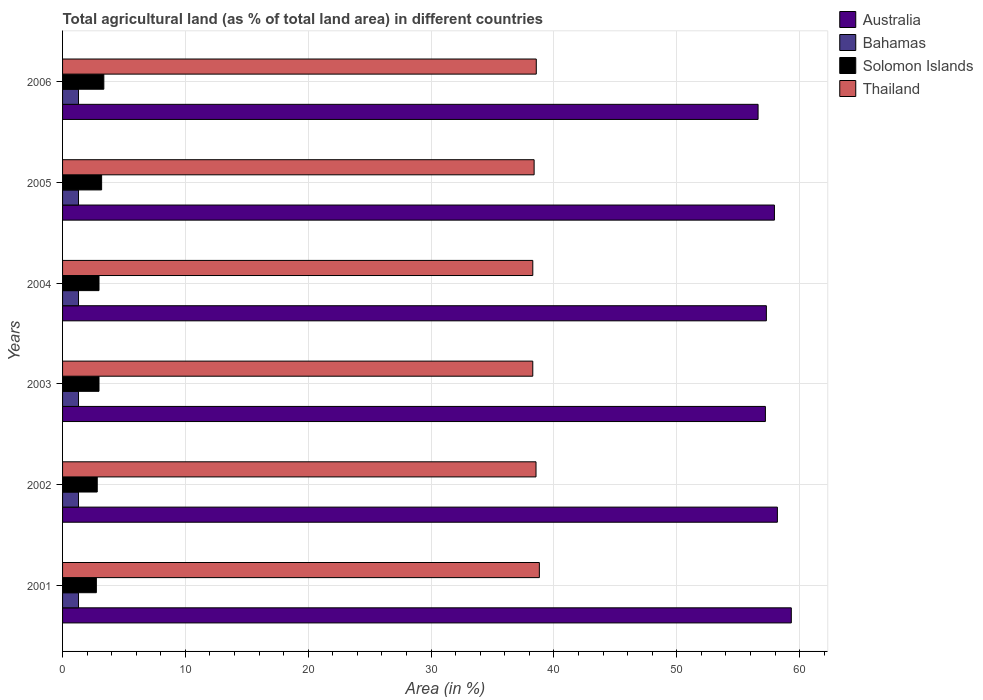How many groups of bars are there?
Provide a short and direct response. 6. Are the number of bars per tick equal to the number of legend labels?
Your response must be concise. Yes. In how many cases, is the number of bars for a given year not equal to the number of legend labels?
Keep it short and to the point. 0. What is the percentage of agricultural land in Australia in 2002?
Ensure brevity in your answer.  58.19. Across all years, what is the maximum percentage of agricultural land in Australia?
Your answer should be very brief. 59.32. Across all years, what is the minimum percentage of agricultural land in Bahamas?
Provide a succinct answer. 1.3. What is the total percentage of agricultural land in Solomon Islands in the graph?
Your answer should be compact. 18.04. What is the difference between the percentage of agricultural land in Bahamas in 2003 and that in 2006?
Give a very brief answer. 0. What is the difference between the percentage of agricultural land in Australia in 2006 and the percentage of agricultural land in Bahamas in 2005?
Give a very brief answer. 55.32. What is the average percentage of agricultural land in Thailand per year?
Your answer should be compact. 38.47. In the year 2003, what is the difference between the percentage of agricultural land in Thailand and percentage of agricultural land in Bahamas?
Provide a succinct answer. 36.98. What is the ratio of the percentage of agricultural land in Solomon Islands in 2002 to that in 2004?
Ensure brevity in your answer.  0.95. What is the difference between the highest and the second highest percentage of agricultural land in Solomon Islands?
Offer a very short reply. 0.18. What is the difference between the highest and the lowest percentage of agricultural land in Solomon Islands?
Make the answer very short. 0.61. Is it the case that in every year, the sum of the percentage of agricultural land in Solomon Islands and percentage of agricultural land in Australia is greater than the sum of percentage of agricultural land in Thailand and percentage of agricultural land in Bahamas?
Give a very brief answer. Yes. What does the 3rd bar from the top in 2001 represents?
Offer a terse response. Bahamas. What does the 4th bar from the bottom in 2006 represents?
Offer a very short reply. Thailand. Is it the case that in every year, the sum of the percentage of agricultural land in Bahamas and percentage of agricultural land in Thailand is greater than the percentage of agricultural land in Solomon Islands?
Your answer should be compact. Yes. How many bars are there?
Offer a terse response. 24. What is the difference between two consecutive major ticks on the X-axis?
Give a very brief answer. 10. Are the values on the major ticks of X-axis written in scientific E-notation?
Give a very brief answer. No. Does the graph contain grids?
Make the answer very short. Yes. How are the legend labels stacked?
Provide a succinct answer. Vertical. What is the title of the graph?
Your answer should be compact. Total agricultural land (as % of total land area) in different countries. What is the label or title of the X-axis?
Your answer should be very brief. Area (in %). What is the Area (in %) in Australia in 2001?
Your answer should be compact. 59.32. What is the Area (in %) of Bahamas in 2001?
Provide a short and direct response. 1.3. What is the Area (in %) in Solomon Islands in 2001?
Provide a short and direct response. 2.75. What is the Area (in %) in Thailand in 2001?
Make the answer very short. 38.81. What is the Area (in %) of Australia in 2002?
Keep it short and to the point. 58.19. What is the Area (in %) in Bahamas in 2002?
Offer a very short reply. 1.3. What is the Area (in %) in Solomon Islands in 2002?
Your answer should be very brief. 2.82. What is the Area (in %) of Thailand in 2002?
Your response must be concise. 38.54. What is the Area (in %) in Australia in 2003?
Your answer should be very brief. 57.21. What is the Area (in %) of Bahamas in 2003?
Keep it short and to the point. 1.3. What is the Area (in %) of Solomon Islands in 2003?
Provide a succinct answer. 2.97. What is the Area (in %) in Thailand in 2003?
Your answer should be compact. 38.27. What is the Area (in %) of Australia in 2004?
Give a very brief answer. 57.29. What is the Area (in %) in Bahamas in 2004?
Provide a short and direct response. 1.3. What is the Area (in %) in Solomon Islands in 2004?
Give a very brief answer. 2.97. What is the Area (in %) in Thailand in 2004?
Give a very brief answer. 38.28. What is the Area (in %) of Australia in 2005?
Ensure brevity in your answer.  57.94. What is the Area (in %) in Bahamas in 2005?
Your response must be concise. 1.3. What is the Area (in %) in Solomon Islands in 2005?
Your answer should be very brief. 3.18. What is the Area (in %) in Thailand in 2005?
Offer a very short reply. 38.38. What is the Area (in %) of Australia in 2006?
Make the answer very short. 56.61. What is the Area (in %) in Bahamas in 2006?
Your response must be concise. 1.3. What is the Area (in %) in Solomon Islands in 2006?
Ensure brevity in your answer.  3.36. What is the Area (in %) of Thailand in 2006?
Provide a short and direct response. 38.56. Across all years, what is the maximum Area (in %) of Australia?
Your answer should be very brief. 59.32. Across all years, what is the maximum Area (in %) in Bahamas?
Make the answer very short. 1.3. Across all years, what is the maximum Area (in %) of Solomon Islands?
Provide a succinct answer. 3.36. Across all years, what is the maximum Area (in %) of Thailand?
Your answer should be compact. 38.81. Across all years, what is the minimum Area (in %) of Australia?
Your answer should be compact. 56.61. Across all years, what is the minimum Area (in %) of Bahamas?
Ensure brevity in your answer.  1.3. Across all years, what is the minimum Area (in %) of Solomon Islands?
Offer a very short reply. 2.75. Across all years, what is the minimum Area (in %) in Thailand?
Your answer should be very brief. 38.27. What is the total Area (in %) of Australia in the graph?
Your answer should be very brief. 346.56. What is the total Area (in %) in Bahamas in the graph?
Keep it short and to the point. 7.79. What is the total Area (in %) of Solomon Islands in the graph?
Your answer should be very brief. 18.04. What is the total Area (in %) in Thailand in the graph?
Your answer should be compact. 230.84. What is the difference between the Area (in %) in Australia in 2001 and that in 2002?
Make the answer very short. 1.13. What is the difference between the Area (in %) in Bahamas in 2001 and that in 2002?
Offer a terse response. 0. What is the difference between the Area (in %) of Solomon Islands in 2001 and that in 2002?
Your answer should be very brief. -0.07. What is the difference between the Area (in %) of Thailand in 2001 and that in 2002?
Your answer should be very brief. 0.27. What is the difference between the Area (in %) of Australia in 2001 and that in 2003?
Your answer should be very brief. 2.11. What is the difference between the Area (in %) in Solomon Islands in 2001 and that in 2003?
Offer a very short reply. -0.21. What is the difference between the Area (in %) of Thailand in 2001 and that in 2003?
Offer a very short reply. 0.54. What is the difference between the Area (in %) in Australia in 2001 and that in 2004?
Give a very brief answer. 2.03. What is the difference between the Area (in %) of Solomon Islands in 2001 and that in 2004?
Offer a very short reply. -0.21. What is the difference between the Area (in %) in Thailand in 2001 and that in 2004?
Your response must be concise. 0.53. What is the difference between the Area (in %) in Australia in 2001 and that in 2005?
Your response must be concise. 1.37. What is the difference between the Area (in %) in Bahamas in 2001 and that in 2005?
Provide a short and direct response. 0. What is the difference between the Area (in %) in Solomon Islands in 2001 and that in 2005?
Provide a short and direct response. -0.43. What is the difference between the Area (in %) in Thailand in 2001 and that in 2005?
Make the answer very short. 0.43. What is the difference between the Area (in %) in Australia in 2001 and that in 2006?
Offer a very short reply. 2.7. What is the difference between the Area (in %) of Solomon Islands in 2001 and that in 2006?
Provide a succinct answer. -0.61. What is the difference between the Area (in %) of Thailand in 2001 and that in 2006?
Your response must be concise. 0.25. What is the difference between the Area (in %) in Australia in 2002 and that in 2003?
Ensure brevity in your answer.  0.98. What is the difference between the Area (in %) of Bahamas in 2002 and that in 2003?
Make the answer very short. 0. What is the difference between the Area (in %) of Solomon Islands in 2002 and that in 2003?
Offer a terse response. -0.14. What is the difference between the Area (in %) of Thailand in 2002 and that in 2003?
Provide a short and direct response. 0.26. What is the difference between the Area (in %) of Australia in 2002 and that in 2004?
Provide a short and direct response. 0.9. What is the difference between the Area (in %) of Bahamas in 2002 and that in 2004?
Give a very brief answer. 0. What is the difference between the Area (in %) of Solomon Islands in 2002 and that in 2004?
Your answer should be compact. -0.14. What is the difference between the Area (in %) of Thailand in 2002 and that in 2004?
Your answer should be very brief. 0.26. What is the difference between the Area (in %) in Australia in 2002 and that in 2005?
Your response must be concise. 0.24. What is the difference between the Area (in %) of Solomon Islands in 2002 and that in 2005?
Keep it short and to the point. -0.36. What is the difference between the Area (in %) of Thailand in 2002 and that in 2005?
Ensure brevity in your answer.  0.15. What is the difference between the Area (in %) in Australia in 2002 and that in 2006?
Ensure brevity in your answer.  1.57. What is the difference between the Area (in %) in Bahamas in 2002 and that in 2006?
Your answer should be very brief. 0. What is the difference between the Area (in %) of Solomon Islands in 2002 and that in 2006?
Provide a succinct answer. -0.54. What is the difference between the Area (in %) in Thailand in 2002 and that in 2006?
Give a very brief answer. -0.02. What is the difference between the Area (in %) of Australia in 2003 and that in 2004?
Keep it short and to the point. -0.08. What is the difference between the Area (in %) of Thailand in 2003 and that in 2004?
Provide a short and direct response. -0. What is the difference between the Area (in %) of Australia in 2003 and that in 2005?
Offer a very short reply. -0.74. What is the difference between the Area (in %) of Bahamas in 2003 and that in 2005?
Offer a very short reply. 0. What is the difference between the Area (in %) of Solomon Islands in 2003 and that in 2005?
Offer a terse response. -0.21. What is the difference between the Area (in %) in Thailand in 2003 and that in 2005?
Ensure brevity in your answer.  -0.11. What is the difference between the Area (in %) in Australia in 2003 and that in 2006?
Provide a succinct answer. 0.6. What is the difference between the Area (in %) in Bahamas in 2003 and that in 2006?
Make the answer very short. 0. What is the difference between the Area (in %) of Solomon Islands in 2003 and that in 2006?
Give a very brief answer. -0.39. What is the difference between the Area (in %) of Thailand in 2003 and that in 2006?
Offer a very short reply. -0.29. What is the difference between the Area (in %) of Australia in 2004 and that in 2005?
Ensure brevity in your answer.  -0.66. What is the difference between the Area (in %) in Bahamas in 2004 and that in 2005?
Offer a very short reply. 0. What is the difference between the Area (in %) in Solomon Islands in 2004 and that in 2005?
Give a very brief answer. -0.21. What is the difference between the Area (in %) in Thailand in 2004 and that in 2005?
Provide a short and direct response. -0.11. What is the difference between the Area (in %) of Australia in 2004 and that in 2006?
Offer a very short reply. 0.67. What is the difference between the Area (in %) in Bahamas in 2004 and that in 2006?
Your answer should be very brief. 0. What is the difference between the Area (in %) in Solomon Islands in 2004 and that in 2006?
Offer a very short reply. -0.39. What is the difference between the Area (in %) in Thailand in 2004 and that in 2006?
Ensure brevity in your answer.  -0.28. What is the difference between the Area (in %) of Australia in 2005 and that in 2006?
Ensure brevity in your answer.  1.33. What is the difference between the Area (in %) in Bahamas in 2005 and that in 2006?
Your answer should be compact. 0. What is the difference between the Area (in %) of Solomon Islands in 2005 and that in 2006?
Offer a terse response. -0.18. What is the difference between the Area (in %) in Thailand in 2005 and that in 2006?
Give a very brief answer. -0.18. What is the difference between the Area (in %) in Australia in 2001 and the Area (in %) in Bahamas in 2002?
Keep it short and to the point. 58.02. What is the difference between the Area (in %) of Australia in 2001 and the Area (in %) of Solomon Islands in 2002?
Give a very brief answer. 56.5. What is the difference between the Area (in %) of Australia in 2001 and the Area (in %) of Thailand in 2002?
Your response must be concise. 20.78. What is the difference between the Area (in %) in Bahamas in 2001 and the Area (in %) in Solomon Islands in 2002?
Your response must be concise. -1.52. What is the difference between the Area (in %) of Bahamas in 2001 and the Area (in %) of Thailand in 2002?
Provide a short and direct response. -37.24. What is the difference between the Area (in %) of Solomon Islands in 2001 and the Area (in %) of Thailand in 2002?
Your answer should be compact. -35.79. What is the difference between the Area (in %) of Australia in 2001 and the Area (in %) of Bahamas in 2003?
Give a very brief answer. 58.02. What is the difference between the Area (in %) of Australia in 2001 and the Area (in %) of Solomon Islands in 2003?
Keep it short and to the point. 56.35. What is the difference between the Area (in %) in Australia in 2001 and the Area (in %) in Thailand in 2003?
Your answer should be very brief. 21.04. What is the difference between the Area (in %) in Bahamas in 2001 and the Area (in %) in Solomon Islands in 2003?
Ensure brevity in your answer.  -1.67. What is the difference between the Area (in %) of Bahamas in 2001 and the Area (in %) of Thailand in 2003?
Your answer should be compact. -36.98. What is the difference between the Area (in %) of Solomon Islands in 2001 and the Area (in %) of Thailand in 2003?
Your answer should be compact. -35.52. What is the difference between the Area (in %) in Australia in 2001 and the Area (in %) in Bahamas in 2004?
Give a very brief answer. 58.02. What is the difference between the Area (in %) of Australia in 2001 and the Area (in %) of Solomon Islands in 2004?
Offer a terse response. 56.35. What is the difference between the Area (in %) in Australia in 2001 and the Area (in %) in Thailand in 2004?
Offer a very short reply. 21.04. What is the difference between the Area (in %) of Bahamas in 2001 and the Area (in %) of Solomon Islands in 2004?
Offer a very short reply. -1.67. What is the difference between the Area (in %) in Bahamas in 2001 and the Area (in %) in Thailand in 2004?
Provide a succinct answer. -36.98. What is the difference between the Area (in %) in Solomon Islands in 2001 and the Area (in %) in Thailand in 2004?
Offer a very short reply. -35.53. What is the difference between the Area (in %) in Australia in 2001 and the Area (in %) in Bahamas in 2005?
Your answer should be very brief. 58.02. What is the difference between the Area (in %) of Australia in 2001 and the Area (in %) of Solomon Islands in 2005?
Provide a short and direct response. 56.14. What is the difference between the Area (in %) in Australia in 2001 and the Area (in %) in Thailand in 2005?
Your response must be concise. 20.93. What is the difference between the Area (in %) of Bahamas in 2001 and the Area (in %) of Solomon Islands in 2005?
Ensure brevity in your answer.  -1.88. What is the difference between the Area (in %) in Bahamas in 2001 and the Area (in %) in Thailand in 2005?
Your answer should be very brief. -37.09. What is the difference between the Area (in %) of Solomon Islands in 2001 and the Area (in %) of Thailand in 2005?
Your answer should be very brief. -35.63. What is the difference between the Area (in %) in Australia in 2001 and the Area (in %) in Bahamas in 2006?
Give a very brief answer. 58.02. What is the difference between the Area (in %) in Australia in 2001 and the Area (in %) in Solomon Islands in 2006?
Provide a succinct answer. 55.96. What is the difference between the Area (in %) in Australia in 2001 and the Area (in %) in Thailand in 2006?
Offer a very short reply. 20.76. What is the difference between the Area (in %) in Bahamas in 2001 and the Area (in %) in Solomon Islands in 2006?
Provide a short and direct response. -2.06. What is the difference between the Area (in %) of Bahamas in 2001 and the Area (in %) of Thailand in 2006?
Your answer should be compact. -37.26. What is the difference between the Area (in %) of Solomon Islands in 2001 and the Area (in %) of Thailand in 2006?
Ensure brevity in your answer.  -35.81. What is the difference between the Area (in %) in Australia in 2002 and the Area (in %) in Bahamas in 2003?
Give a very brief answer. 56.89. What is the difference between the Area (in %) in Australia in 2002 and the Area (in %) in Solomon Islands in 2003?
Offer a very short reply. 55.22. What is the difference between the Area (in %) of Australia in 2002 and the Area (in %) of Thailand in 2003?
Offer a very short reply. 19.91. What is the difference between the Area (in %) of Bahamas in 2002 and the Area (in %) of Solomon Islands in 2003?
Your answer should be very brief. -1.67. What is the difference between the Area (in %) in Bahamas in 2002 and the Area (in %) in Thailand in 2003?
Offer a very short reply. -36.98. What is the difference between the Area (in %) in Solomon Islands in 2002 and the Area (in %) in Thailand in 2003?
Ensure brevity in your answer.  -35.45. What is the difference between the Area (in %) of Australia in 2002 and the Area (in %) of Bahamas in 2004?
Ensure brevity in your answer.  56.89. What is the difference between the Area (in %) of Australia in 2002 and the Area (in %) of Solomon Islands in 2004?
Ensure brevity in your answer.  55.22. What is the difference between the Area (in %) in Australia in 2002 and the Area (in %) in Thailand in 2004?
Your response must be concise. 19.91. What is the difference between the Area (in %) in Bahamas in 2002 and the Area (in %) in Solomon Islands in 2004?
Your answer should be compact. -1.67. What is the difference between the Area (in %) of Bahamas in 2002 and the Area (in %) of Thailand in 2004?
Ensure brevity in your answer.  -36.98. What is the difference between the Area (in %) of Solomon Islands in 2002 and the Area (in %) of Thailand in 2004?
Your response must be concise. -35.45. What is the difference between the Area (in %) of Australia in 2002 and the Area (in %) of Bahamas in 2005?
Provide a short and direct response. 56.89. What is the difference between the Area (in %) of Australia in 2002 and the Area (in %) of Solomon Islands in 2005?
Offer a very short reply. 55.01. What is the difference between the Area (in %) in Australia in 2002 and the Area (in %) in Thailand in 2005?
Ensure brevity in your answer.  19.8. What is the difference between the Area (in %) in Bahamas in 2002 and the Area (in %) in Solomon Islands in 2005?
Make the answer very short. -1.88. What is the difference between the Area (in %) in Bahamas in 2002 and the Area (in %) in Thailand in 2005?
Your response must be concise. -37.09. What is the difference between the Area (in %) of Solomon Islands in 2002 and the Area (in %) of Thailand in 2005?
Give a very brief answer. -35.56. What is the difference between the Area (in %) of Australia in 2002 and the Area (in %) of Bahamas in 2006?
Give a very brief answer. 56.89. What is the difference between the Area (in %) of Australia in 2002 and the Area (in %) of Solomon Islands in 2006?
Ensure brevity in your answer.  54.83. What is the difference between the Area (in %) in Australia in 2002 and the Area (in %) in Thailand in 2006?
Your response must be concise. 19.63. What is the difference between the Area (in %) of Bahamas in 2002 and the Area (in %) of Solomon Islands in 2006?
Keep it short and to the point. -2.06. What is the difference between the Area (in %) of Bahamas in 2002 and the Area (in %) of Thailand in 2006?
Provide a succinct answer. -37.26. What is the difference between the Area (in %) of Solomon Islands in 2002 and the Area (in %) of Thailand in 2006?
Provide a short and direct response. -35.74. What is the difference between the Area (in %) in Australia in 2003 and the Area (in %) in Bahamas in 2004?
Offer a terse response. 55.91. What is the difference between the Area (in %) in Australia in 2003 and the Area (in %) in Solomon Islands in 2004?
Provide a succinct answer. 54.24. What is the difference between the Area (in %) in Australia in 2003 and the Area (in %) in Thailand in 2004?
Your answer should be compact. 18.93. What is the difference between the Area (in %) of Bahamas in 2003 and the Area (in %) of Solomon Islands in 2004?
Offer a very short reply. -1.67. What is the difference between the Area (in %) in Bahamas in 2003 and the Area (in %) in Thailand in 2004?
Ensure brevity in your answer.  -36.98. What is the difference between the Area (in %) in Solomon Islands in 2003 and the Area (in %) in Thailand in 2004?
Your answer should be compact. -35.31. What is the difference between the Area (in %) of Australia in 2003 and the Area (in %) of Bahamas in 2005?
Offer a terse response. 55.91. What is the difference between the Area (in %) of Australia in 2003 and the Area (in %) of Solomon Islands in 2005?
Ensure brevity in your answer.  54.03. What is the difference between the Area (in %) in Australia in 2003 and the Area (in %) in Thailand in 2005?
Provide a succinct answer. 18.83. What is the difference between the Area (in %) in Bahamas in 2003 and the Area (in %) in Solomon Islands in 2005?
Provide a succinct answer. -1.88. What is the difference between the Area (in %) in Bahamas in 2003 and the Area (in %) in Thailand in 2005?
Your answer should be very brief. -37.09. What is the difference between the Area (in %) of Solomon Islands in 2003 and the Area (in %) of Thailand in 2005?
Offer a very short reply. -35.42. What is the difference between the Area (in %) of Australia in 2003 and the Area (in %) of Bahamas in 2006?
Your answer should be very brief. 55.91. What is the difference between the Area (in %) in Australia in 2003 and the Area (in %) in Solomon Islands in 2006?
Offer a terse response. 53.85. What is the difference between the Area (in %) of Australia in 2003 and the Area (in %) of Thailand in 2006?
Keep it short and to the point. 18.65. What is the difference between the Area (in %) of Bahamas in 2003 and the Area (in %) of Solomon Islands in 2006?
Provide a succinct answer. -2.06. What is the difference between the Area (in %) of Bahamas in 2003 and the Area (in %) of Thailand in 2006?
Keep it short and to the point. -37.26. What is the difference between the Area (in %) in Solomon Islands in 2003 and the Area (in %) in Thailand in 2006?
Ensure brevity in your answer.  -35.59. What is the difference between the Area (in %) of Australia in 2004 and the Area (in %) of Bahamas in 2005?
Offer a very short reply. 55.99. What is the difference between the Area (in %) in Australia in 2004 and the Area (in %) in Solomon Islands in 2005?
Your response must be concise. 54.11. What is the difference between the Area (in %) in Australia in 2004 and the Area (in %) in Thailand in 2005?
Offer a terse response. 18.9. What is the difference between the Area (in %) in Bahamas in 2004 and the Area (in %) in Solomon Islands in 2005?
Give a very brief answer. -1.88. What is the difference between the Area (in %) in Bahamas in 2004 and the Area (in %) in Thailand in 2005?
Your answer should be very brief. -37.09. What is the difference between the Area (in %) of Solomon Islands in 2004 and the Area (in %) of Thailand in 2005?
Ensure brevity in your answer.  -35.42. What is the difference between the Area (in %) in Australia in 2004 and the Area (in %) in Bahamas in 2006?
Provide a succinct answer. 55.99. What is the difference between the Area (in %) of Australia in 2004 and the Area (in %) of Solomon Islands in 2006?
Give a very brief answer. 53.93. What is the difference between the Area (in %) in Australia in 2004 and the Area (in %) in Thailand in 2006?
Provide a short and direct response. 18.73. What is the difference between the Area (in %) of Bahamas in 2004 and the Area (in %) of Solomon Islands in 2006?
Offer a terse response. -2.06. What is the difference between the Area (in %) in Bahamas in 2004 and the Area (in %) in Thailand in 2006?
Make the answer very short. -37.26. What is the difference between the Area (in %) in Solomon Islands in 2004 and the Area (in %) in Thailand in 2006?
Your response must be concise. -35.59. What is the difference between the Area (in %) of Australia in 2005 and the Area (in %) of Bahamas in 2006?
Your answer should be compact. 56.65. What is the difference between the Area (in %) in Australia in 2005 and the Area (in %) in Solomon Islands in 2006?
Offer a terse response. 54.59. What is the difference between the Area (in %) in Australia in 2005 and the Area (in %) in Thailand in 2006?
Ensure brevity in your answer.  19.38. What is the difference between the Area (in %) of Bahamas in 2005 and the Area (in %) of Solomon Islands in 2006?
Provide a succinct answer. -2.06. What is the difference between the Area (in %) of Bahamas in 2005 and the Area (in %) of Thailand in 2006?
Keep it short and to the point. -37.26. What is the difference between the Area (in %) in Solomon Islands in 2005 and the Area (in %) in Thailand in 2006?
Offer a terse response. -35.38. What is the average Area (in %) of Australia per year?
Give a very brief answer. 57.76. What is the average Area (in %) of Bahamas per year?
Provide a succinct answer. 1.3. What is the average Area (in %) in Solomon Islands per year?
Provide a short and direct response. 3.01. What is the average Area (in %) in Thailand per year?
Offer a very short reply. 38.47. In the year 2001, what is the difference between the Area (in %) of Australia and Area (in %) of Bahamas?
Your answer should be very brief. 58.02. In the year 2001, what is the difference between the Area (in %) in Australia and Area (in %) in Solomon Islands?
Give a very brief answer. 56.57. In the year 2001, what is the difference between the Area (in %) of Australia and Area (in %) of Thailand?
Your response must be concise. 20.51. In the year 2001, what is the difference between the Area (in %) in Bahamas and Area (in %) in Solomon Islands?
Ensure brevity in your answer.  -1.45. In the year 2001, what is the difference between the Area (in %) in Bahamas and Area (in %) in Thailand?
Provide a short and direct response. -37.51. In the year 2001, what is the difference between the Area (in %) of Solomon Islands and Area (in %) of Thailand?
Ensure brevity in your answer.  -36.06. In the year 2002, what is the difference between the Area (in %) in Australia and Area (in %) in Bahamas?
Offer a terse response. 56.89. In the year 2002, what is the difference between the Area (in %) of Australia and Area (in %) of Solomon Islands?
Your answer should be very brief. 55.36. In the year 2002, what is the difference between the Area (in %) of Australia and Area (in %) of Thailand?
Offer a terse response. 19.65. In the year 2002, what is the difference between the Area (in %) of Bahamas and Area (in %) of Solomon Islands?
Your answer should be compact. -1.52. In the year 2002, what is the difference between the Area (in %) of Bahamas and Area (in %) of Thailand?
Your answer should be very brief. -37.24. In the year 2002, what is the difference between the Area (in %) in Solomon Islands and Area (in %) in Thailand?
Offer a terse response. -35.72. In the year 2003, what is the difference between the Area (in %) in Australia and Area (in %) in Bahamas?
Your response must be concise. 55.91. In the year 2003, what is the difference between the Area (in %) in Australia and Area (in %) in Solomon Islands?
Offer a terse response. 54.24. In the year 2003, what is the difference between the Area (in %) of Australia and Area (in %) of Thailand?
Make the answer very short. 18.93. In the year 2003, what is the difference between the Area (in %) of Bahamas and Area (in %) of Solomon Islands?
Keep it short and to the point. -1.67. In the year 2003, what is the difference between the Area (in %) of Bahamas and Area (in %) of Thailand?
Your response must be concise. -36.98. In the year 2003, what is the difference between the Area (in %) of Solomon Islands and Area (in %) of Thailand?
Your answer should be compact. -35.31. In the year 2004, what is the difference between the Area (in %) of Australia and Area (in %) of Bahamas?
Offer a very short reply. 55.99. In the year 2004, what is the difference between the Area (in %) in Australia and Area (in %) in Solomon Islands?
Provide a succinct answer. 54.32. In the year 2004, what is the difference between the Area (in %) of Australia and Area (in %) of Thailand?
Your answer should be compact. 19.01. In the year 2004, what is the difference between the Area (in %) of Bahamas and Area (in %) of Solomon Islands?
Give a very brief answer. -1.67. In the year 2004, what is the difference between the Area (in %) in Bahamas and Area (in %) in Thailand?
Give a very brief answer. -36.98. In the year 2004, what is the difference between the Area (in %) in Solomon Islands and Area (in %) in Thailand?
Offer a terse response. -35.31. In the year 2005, what is the difference between the Area (in %) of Australia and Area (in %) of Bahamas?
Your response must be concise. 56.65. In the year 2005, what is the difference between the Area (in %) in Australia and Area (in %) in Solomon Islands?
Make the answer very short. 54.77. In the year 2005, what is the difference between the Area (in %) in Australia and Area (in %) in Thailand?
Give a very brief answer. 19.56. In the year 2005, what is the difference between the Area (in %) of Bahamas and Area (in %) of Solomon Islands?
Your answer should be very brief. -1.88. In the year 2005, what is the difference between the Area (in %) of Bahamas and Area (in %) of Thailand?
Provide a succinct answer. -37.09. In the year 2005, what is the difference between the Area (in %) in Solomon Islands and Area (in %) in Thailand?
Your answer should be very brief. -35.2. In the year 2006, what is the difference between the Area (in %) in Australia and Area (in %) in Bahamas?
Ensure brevity in your answer.  55.32. In the year 2006, what is the difference between the Area (in %) of Australia and Area (in %) of Solomon Islands?
Give a very brief answer. 53.26. In the year 2006, what is the difference between the Area (in %) in Australia and Area (in %) in Thailand?
Make the answer very short. 18.05. In the year 2006, what is the difference between the Area (in %) of Bahamas and Area (in %) of Solomon Islands?
Give a very brief answer. -2.06. In the year 2006, what is the difference between the Area (in %) of Bahamas and Area (in %) of Thailand?
Make the answer very short. -37.26. In the year 2006, what is the difference between the Area (in %) of Solomon Islands and Area (in %) of Thailand?
Your response must be concise. -35.2. What is the ratio of the Area (in %) in Australia in 2001 to that in 2002?
Provide a short and direct response. 1.02. What is the ratio of the Area (in %) in Bahamas in 2001 to that in 2002?
Provide a succinct answer. 1. What is the ratio of the Area (in %) of Solomon Islands in 2001 to that in 2002?
Ensure brevity in your answer.  0.97. What is the ratio of the Area (in %) of Thailand in 2001 to that in 2002?
Your answer should be compact. 1.01. What is the ratio of the Area (in %) of Australia in 2001 to that in 2003?
Provide a succinct answer. 1.04. What is the ratio of the Area (in %) in Solomon Islands in 2001 to that in 2003?
Your answer should be compact. 0.93. What is the ratio of the Area (in %) in Australia in 2001 to that in 2004?
Ensure brevity in your answer.  1.04. What is the ratio of the Area (in %) in Solomon Islands in 2001 to that in 2004?
Offer a terse response. 0.93. What is the ratio of the Area (in %) in Thailand in 2001 to that in 2004?
Offer a terse response. 1.01. What is the ratio of the Area (in %) in Australia in 2001 to that in 2005?
Provide a succinct answer. 1.02. What is the ratio of the Area (in %) of Bahamas in 2001 to that in 2005?
Offer a very short reply. 1. What is the ratio of the Area (in %) in Solomon Islands in 2001 to that in 2005?
Offer a terse response. 0.87. What is the ratio of the Area (in %) in Thailand in 2001 to that in 2005?
Make the answer very short. 1.01. What is the ratio of the Area (in %) of Australia in 2001 to that in 2006?
Your response must be concise. 1.05. What is the ratio of the Area (in %) in Solomon Islands in 2001 to that in 2006?
Offer a very short reply. 0.82. What is the ratio of the Area (in %) in Thailand in 2001 to that in 2006?
Ensure brevity in your answer.  1.01. What is the ratio of the Area (in %) of Australia in 2002 to that in 2003?
Your answer should be compact. 1.02. What is the ratio of the Area (in %) in Bahamas in 2002 to that in 2003?
Your answer should be compact. 1. What is the ratio of the Area (in %) of Solomon Islands in 2002 to that in 2003?
Your response must be concise. 0.95. What is the ratio of the Area (in %) of Australia in 2002 to that in 2004?
Your answer should be very brief. 1.02. What is the ratio of the Area (in %) in Bahamas in 2002 to that in 2004?
Offer a very short reply. 1. What is the ratio of the Area (in %) in Solomon Islands in 2002 to that in 2004?
Your answer should be very brief. 0.95. What is the ratio of the Area (in %) of Australia in 2002 to that in 2005?
Your answer should be compact. 1. What is the ratio of the Area (in %) in Solomon Islands in 2002 to that in 2005?
Your answer should be very brief. 0.89. What is the ratio of the Area (in %) in Australia in 2002 to that in 2006?
Your answer should be compact. 1.03. What is the ratio of the Area (in %) in Bahamas in 2002 to that in 2006?
Your answer should be very brief. 1. What is the ratio of the Area (in %) in Solomon Islands in 2002 to that in 2006?
Make the answer very short. 0.84. What is the ratio of the Area (in %) in Thailand in 2002 to that in 2006?
Keep it short and to the point. 1. What is the ratio of the Area (in %) of Australia in 2003 to that in 2004?
Your answer should be compact. 1. What is the ratio of the Area (in %) of Bahamas in 2003 to that in 2004?
Ensure brevity in your answer.  1. What is the ratio of the Area (in %) of Solomon Islands in 2003 to that in 2004?
Make the answer very short. 1. What is the ratio of the Area (in %) in Australia in 2003 to that in 2005?
Offer a very short reply. 0.99. What is the ratio of the Area (in %) of Solomon Islands in 2003 to that in 2005?
Provide a short and direct response. 0.93. What is the ratio of the Area (in %) in Thailand in 2003 to that in 2005?
Make the answer very short. 1. What is the ratio of the Area (in %) in Australia in 2003 to that in 2006?
Offer a terse response. 1.01. What is the ratio of the Area (in %) in Solomon Islands in 2003 to that in 2006?
Ensure brevity in your answer.  0.88. What is the ratio of the Area (in %) in Thailand in 2003 to that in 2006?
Keep it short and to the point. 0.99. What is the ratio of the Area (in %) in Australia in 2004 to that in 2005?
Provide a short and direct response. 0.99. What is the ratio of the Area (in %) in Solomon Islands in 2004 to that in 2005?
Provide a succinct answer. 0.93. What is the ratio of the Area (in %) of Thailand in 2004 to that in 2005?
Provide a short and direct response. 1. What is the ratio of the Area (in %) of Australia in 2004 to that in 2006?
Ensure brevity in your answer.  1.01. What is the ratio of the Area (in %) in Bahamas in 2004 to that in 2006?
Your response must be concise. 1. What is the ratio of the Area (in %) of Solomon Islands in 2004 to that in 2006?
Provide a succinct answer. 0.88. What is the ratio of the Area (in %) in Australia in 2005 to that in 2006?
Your answer should be very brief. 1.02. What is the ratio of the Area (in %) of Solomon Islands in 2005 to that in 2006?
Offer a terse response. 0.95. What is the ratio of the Area (in %) in Thailand in 2005 to that in 2006?
Your answer should be compact. 1. What is the difference between the highest and the second highest Area (in %) in Australia?
Provide a short and direct response. 1.13. What is the difference between the highest and the second highest Area (in %) in Solomon Islands?
Provide a succinct answer. 0.18. What is the difference between the highest and the second highest Area (in %) in Thailand?
Ensure brevity in your answer.  0.25. What is the difference between the highest and the lowest Area (in %) in Australia?
Your answer should be very brief. 2.7. What is the difference between the highest and the lowest Area (in %) of Solomon Islands?
Provide a short and direct response. 0.61. What is the difference between the highest and the lowest Area (in %) in Thailand?
Keep it short and to the point. 0.54. 